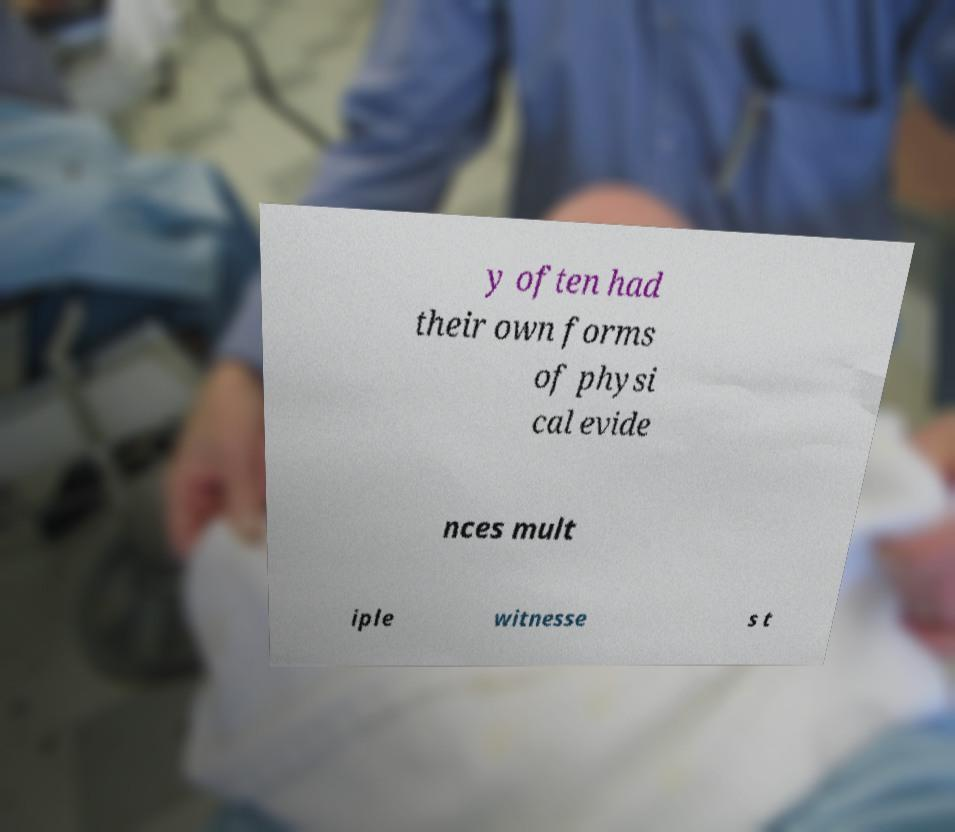Please read and relay the text visible in this image. What does it say? y often had their own forms of physi cal evide nces mult iple witnesse s t 